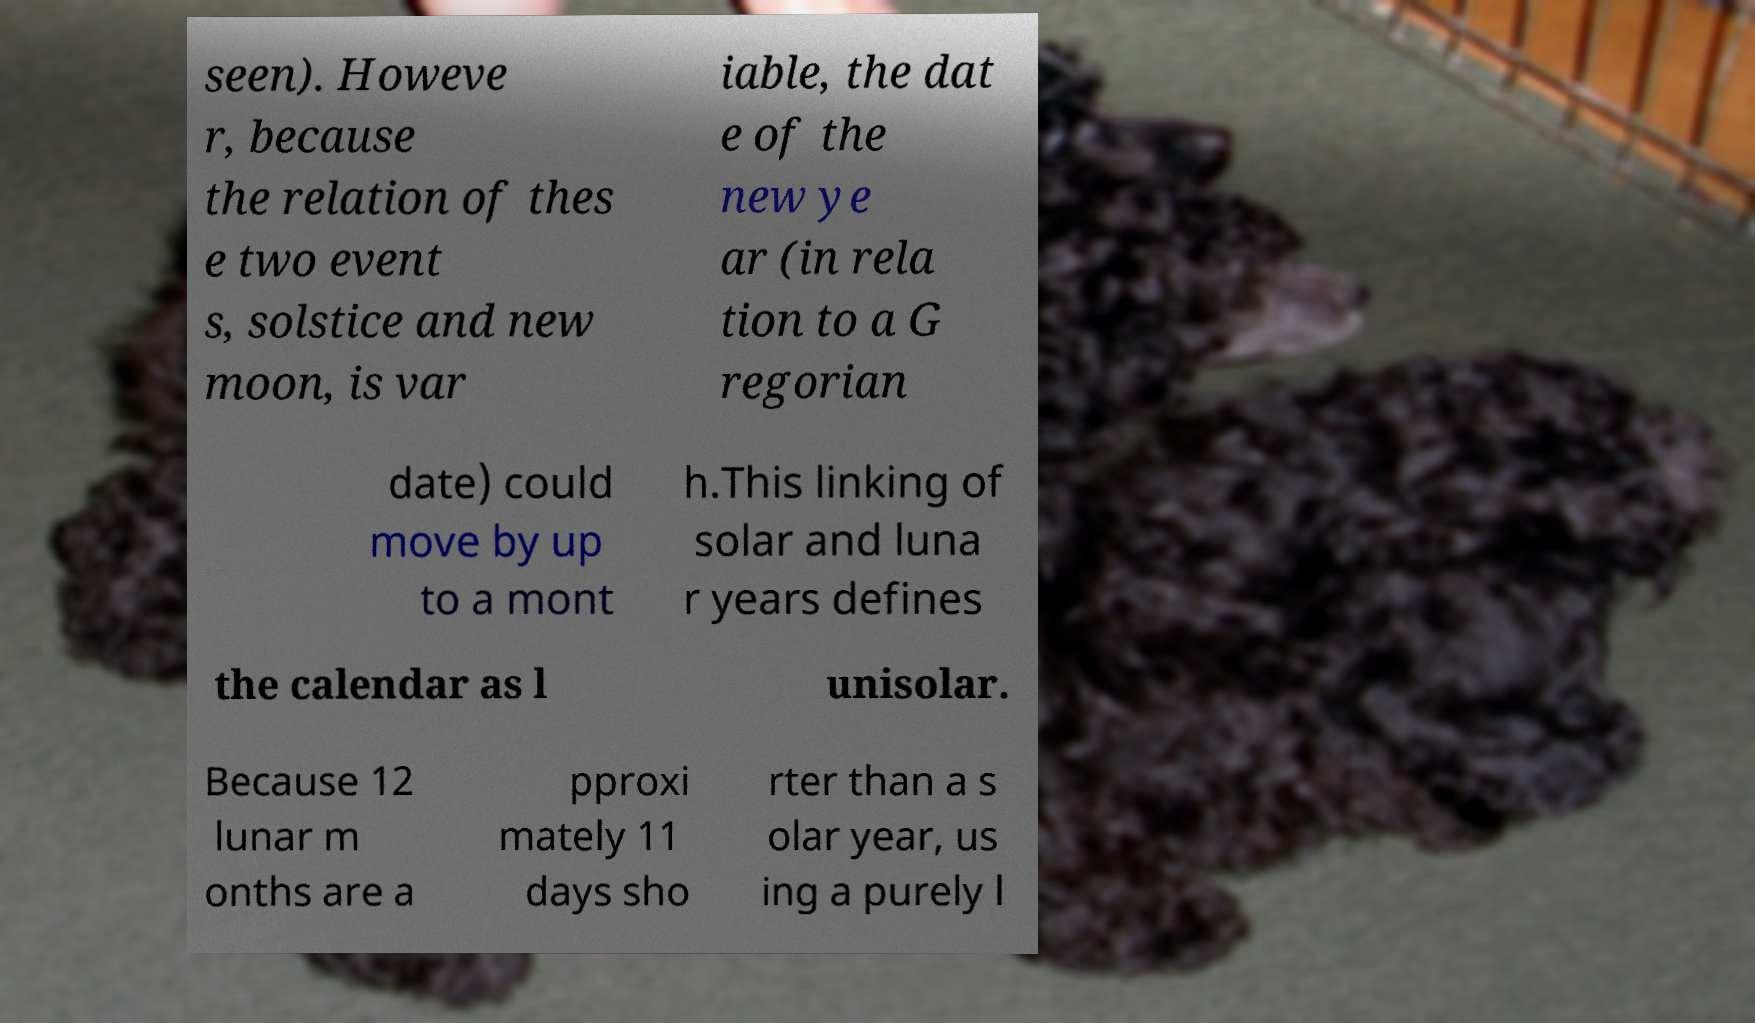Could you assist in decoding the text presented in this image and type it out clearly? seen). Howeve r, because the relation of thes e two event s, solstice and new moon, is var iable, the dat e of the new ye ar (in rela tion to a G regorian date) could move by up to a mont h.This linking of solar and luna r years defines the calendar as l unisolar. Because 12 lunar m onths are a pproxi mately 11 days sho rter than a s olar year, us ing a purely l 